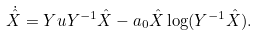<formula> <loc_0><loc_0><loc_500><loc_500>\dot { \hat { X } } & = Y u Y ^ { - 1 } \hat { X } - a _ { 0 } \hat { X } \log ( Y ^ { - 1 } \hat { X } ) .</formula> 